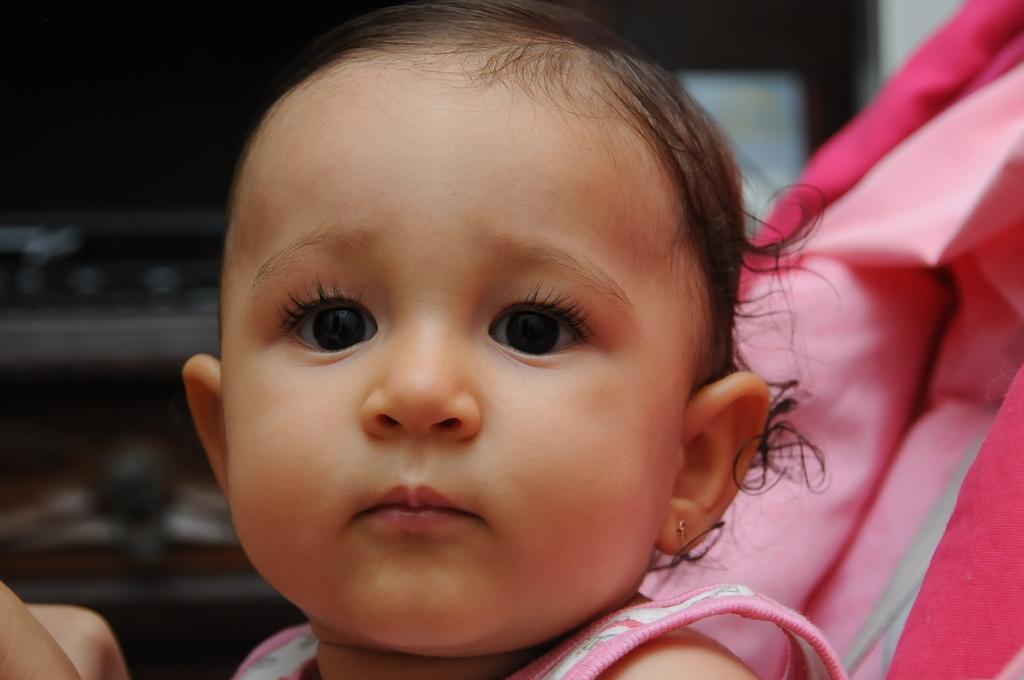Could you give a brief overview of what you see in this image? In this image in the foreground there is one baby, and in the background there are some objects. 